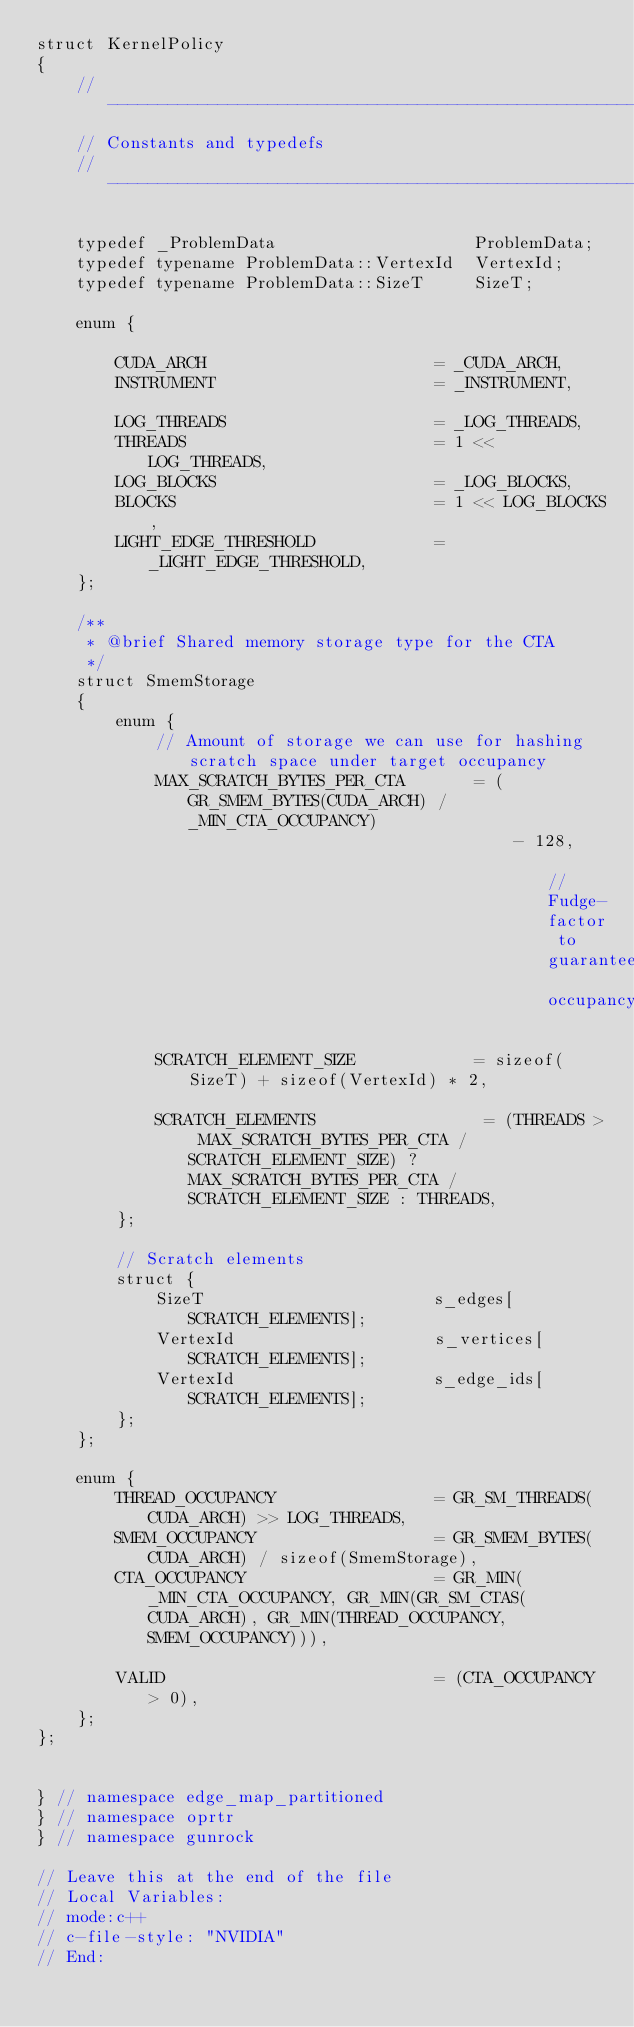Convert code to text. <code><loc_0><loc_0><loc_500><loc_500><_Cuda_>struct KernelPolicy
{
    //---------------------------------------------------------------------
    // Constants and typedefs
    //---------------------------------------------------------------------

    typedef _ProblemData                    ProblemData;
    typedef typename ProblemData::VertexId  VertexId;
    typedef typename ProblemData::SizeT     SizeT;

    enum {

        CUDA_ARCH                       = _CUDA_ARCH,
        INSTRUMENT                      = _INSTRUMENT,

        LOG_THREADS                     = _LOG_THREADS,
        THREADS                         = 1 << LOG_THREADS,
        LOG_BLOCKS                      = _LOG_BLOCKS,
        BLOCKS                          = 1 << LOG_BLOCKS,
        LIGHT_EDGE_THRESHOLD            = _LIGHT_EDGE_THRESHOLD,
    };
    
    /**
     * @brief Shared memory storage type for the CTA
     */
    struct SmemStorage
    {
        enum {
            // Amount of storage we can use for hashing scratch space under target occupancy
            MAX_SCRATCH_BYTES_PER_CTA       = (GR_SMEM_BYTES(CUDA_ARCH) / _MIN_CTA_OCCUPANCY)
                                                - 128,                                          // Fudge-factor to guarantee occupancy

            SCRATCH_ELEMENT_SIZE            = sizeof(SizeT) + sizeof(VertexId) * 2,

            SCRATCH_ELEMENTS                 = (THREADS > MAX_SCRATCH_BYTES_PER_CTA / SCRATCH_ELEMENT_SIZE) ? MAX_SCRATCH_BYTES_PER_CTA / SCRATCH_ELEMENT_SIZE : THREADS,
        };

        // Scratch elements
        struct {
            SizeT                       s_edges[SCRATCH_ELEMENTS];
            VertexId                    s_vertices[SCRATCH_ELEMENTS];
            VertexId                    s_edge_ids[SCRATCH_ELEMENTS];
        };
    };

    enum {
        THREAD_OCCUPANCY                = GR_SM_THREADS(CUDA_ARCH) >> LOG_THREADS,
        SMEM_OCCUPANCY                  = GR_SMEM_BYTES(CUDA_ARCH) / sizeof(SmemStorage),
        CTA_OCCUPANCY                   = GR_MIN(_MIN_CTA_OCCUPANCY, GR_MIN(GR_SM_CTAS(CUDA_ARCH), GR_MIN(THREAD_OCCUPANCY, SMEM_OCCUPANCY))),

        VALID                           = (CTA_OCCUPANCY > 0),
    };
};


} // namespace edge_map_partitioned
} // namespace oprtr
} // namespace gunrock

// Leave this at the end of the file
// Local Variables:
// mode:c++
// c-file-style: "NVIDIA"
// End:
</code> 